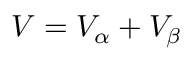Convert formula to latex. <formula><loc_0><loc_0><loc_500><loc_500>V = V _ { \alpha } + V _ { \beta }</formula> 